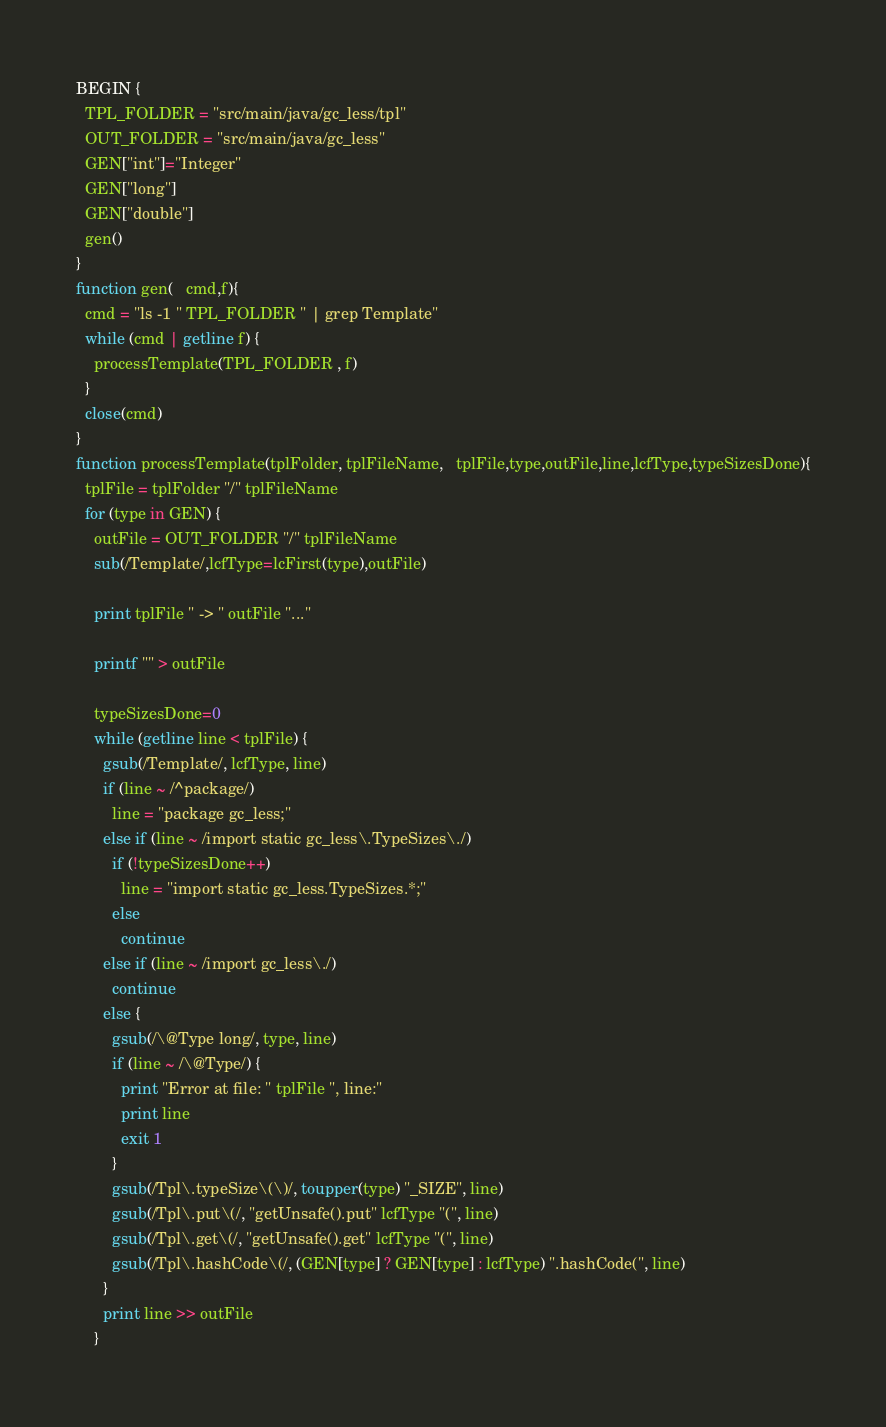<code> <loc_0><loc_0><loc_500><loc_500><_Awk_>BEGIN {
  TPL_FOLDER = "src/main/java/gc_less/tpl"
  OUT_FOLDER = "src/main/java/gc_less"
  GEN["int"]="Integer"
  GEN["long"]
  GEN["double"]
  gen()
}
function gen(   cmd,f){
  cmd = "ls -1 " TPL_FOLDER " | grep Template"
  while (cmd | getline f) {
    processTemplate(TPL_FOLDER , f)
  }
  close(cmd)
}
function processTemplate(tplFolder, tplFileName,   tplFile,type,outFile,line,lcfType,typeSizesDone){
  tplFile = tplFolder "/" tplFileName
  for (type in GEN) {
    outFile = OUT_FOLDER "/" tplFileName
    sub(/Template/,lcfType=lcFirst(type),outFile)

    print tplFile " -> " outFile "..."

    printf "" > outFile

    typeSizesDone=0
    while (getline line < tplFile) {
      gsub(/Template/, lcfType, line)
      if (line ~ /^package/)
        line = "package gc_less;"
      else if (line ~ /import static gc_less\.TypeSizes\./)
        if (!typeSizesDone++)
          line = "import static gc_less.TypeSizes.*;"
        else
          continue
      else if (line ~ /import gc_less\./)
        continue
      else {
        gsub(/\@Type long/, type, line)
        if (line ~ /\@Type/) {
          print "Error at file: " tplFile ", line:"
          print line
          exit 1
        }
        gsub(/Tpl\.typeSize\(\)/, toupper(type) "_SIZE", line)
        gsub(/Tpl\.put\(/, "getUnsafe().put" lcfType "(", line)
        gsub(/Tpl\.get\(/, "getUnsafe().get" lcfType "(", line)
        gsub(/Tpl\.hashCode\(/, (GEN[type] ? GEN[type] : lcfType) ".hashCode(", line)
      }
      print line >> outFile
    }
</code> 